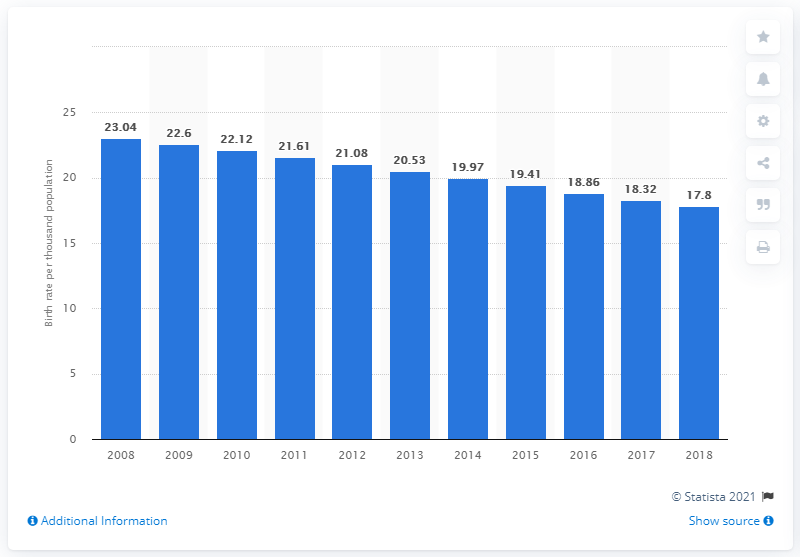Highlight a few significant elements in this photo. In 2018, the crude birth rate in Saudi Arabia was 17.8, which represents the number of live births per 1,000 people in the population. 